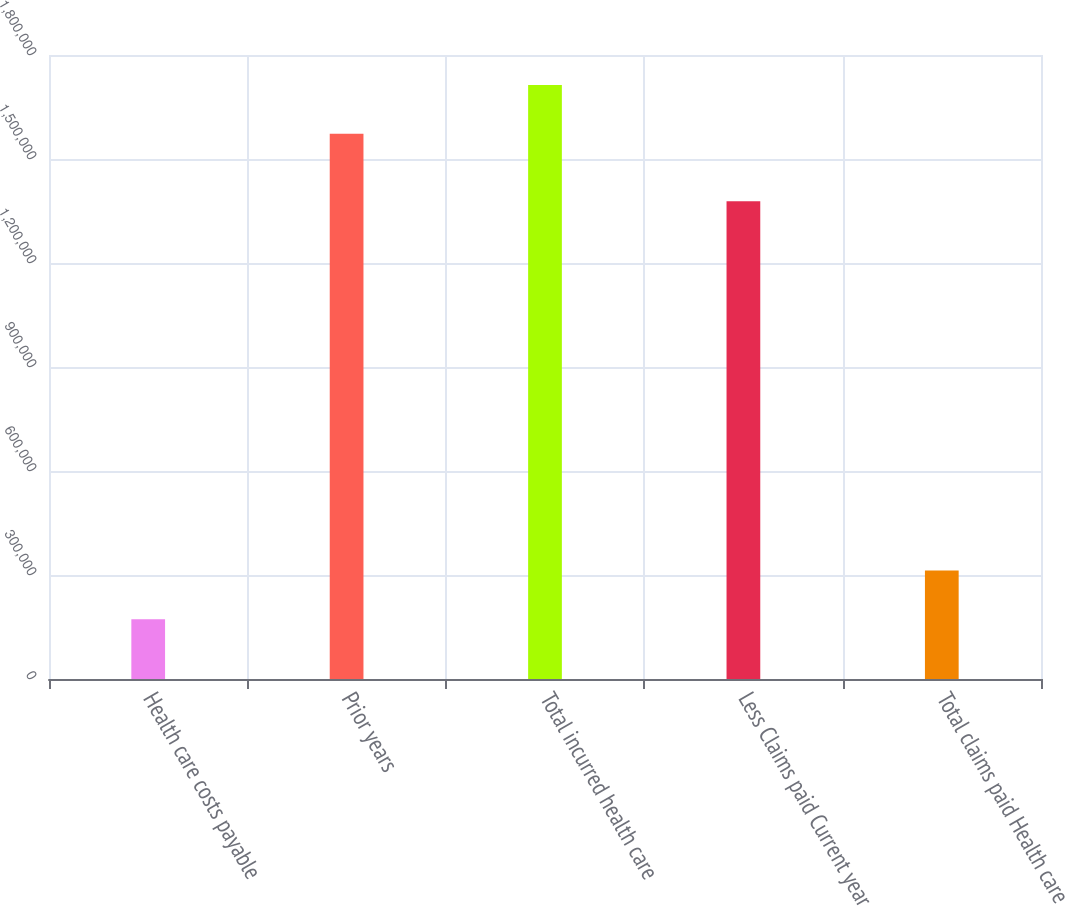<chart> <loc_0><loc_0><loc_500><loc_500><bar_chart><fcel>Health care costs payable<fcel>Prior years<fcel>Total incurred health care<fcel>Less Claims paid Current year<fcel>Total claims paid Health care<nl><fcel>172310<fcel>1.57272e+06<fcel>1.71311e+06<fcel>1.37814e+06<fcel>312694<nl></chart> 